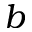Convert formula to latex. <formula><loc_0><loc_0><loc_500><loc_500>b</formula> 